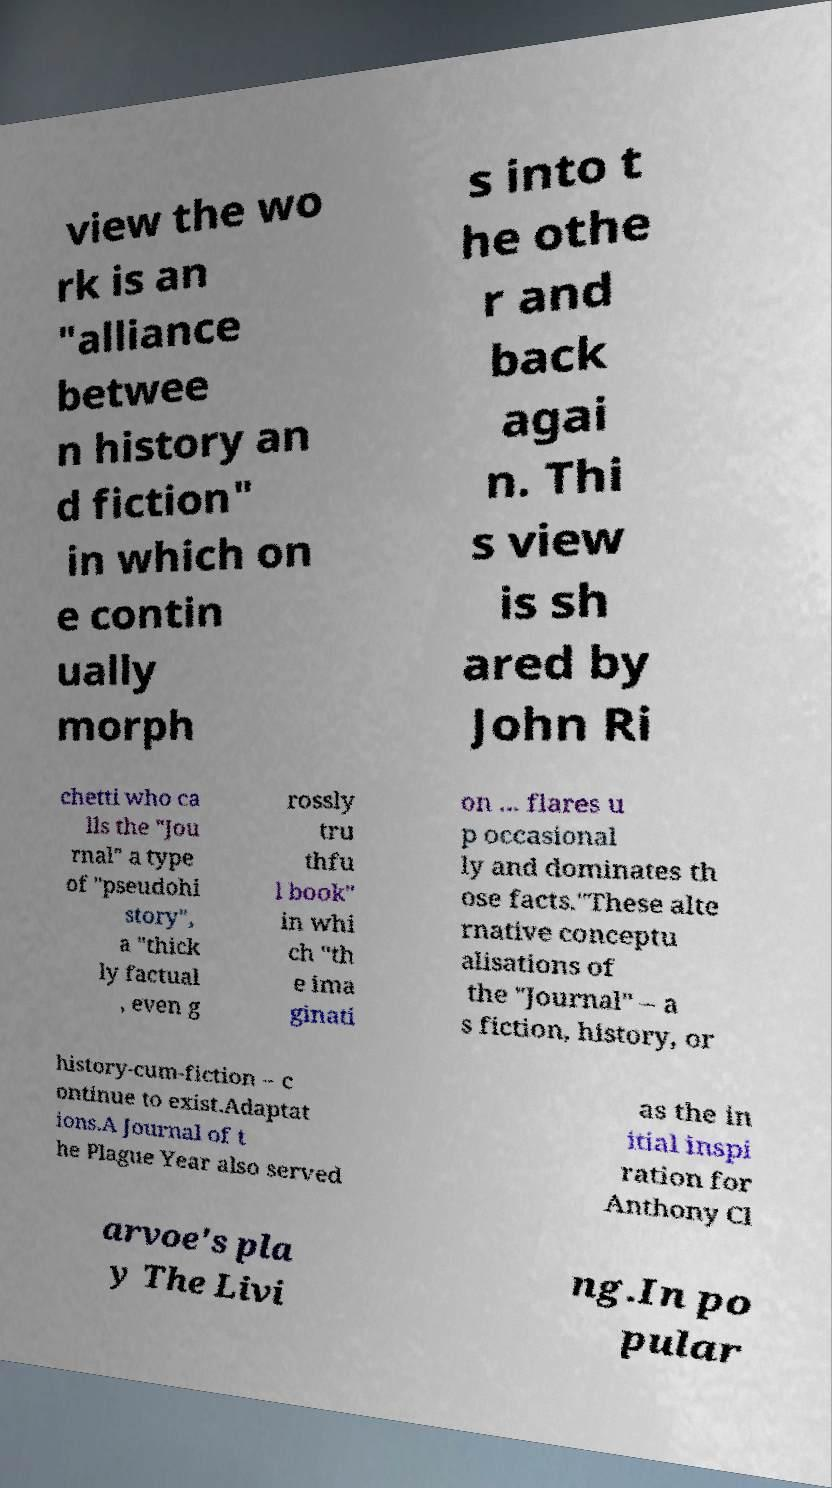There's text embedded in this image that I need extracted. Can you transcribe it verbatim? view the wo rk is an "alliance betwee n history an d fiction" in which on e contin ually morph s into t he othe r and back agai n. Thi s view is sh ared by John Ri chetti who ca lls the "Jou rnal" a type of "pseudohi story", a "thick ly factual , even g rossly tru thfu l book" in whi ch "th e ima ginati on ... flares u p occasional ly and dominates th ose facts."These alte rnative conceptu alisations of the "Journal" – a s fiction, history, or history-cum-fiction – c ontinue to exist.Adaptat ions.A Journal of t he Plague Year also served as the in itial inspi ration for Anthony Cl arvoe's pla y The Livi ng.In po pular 